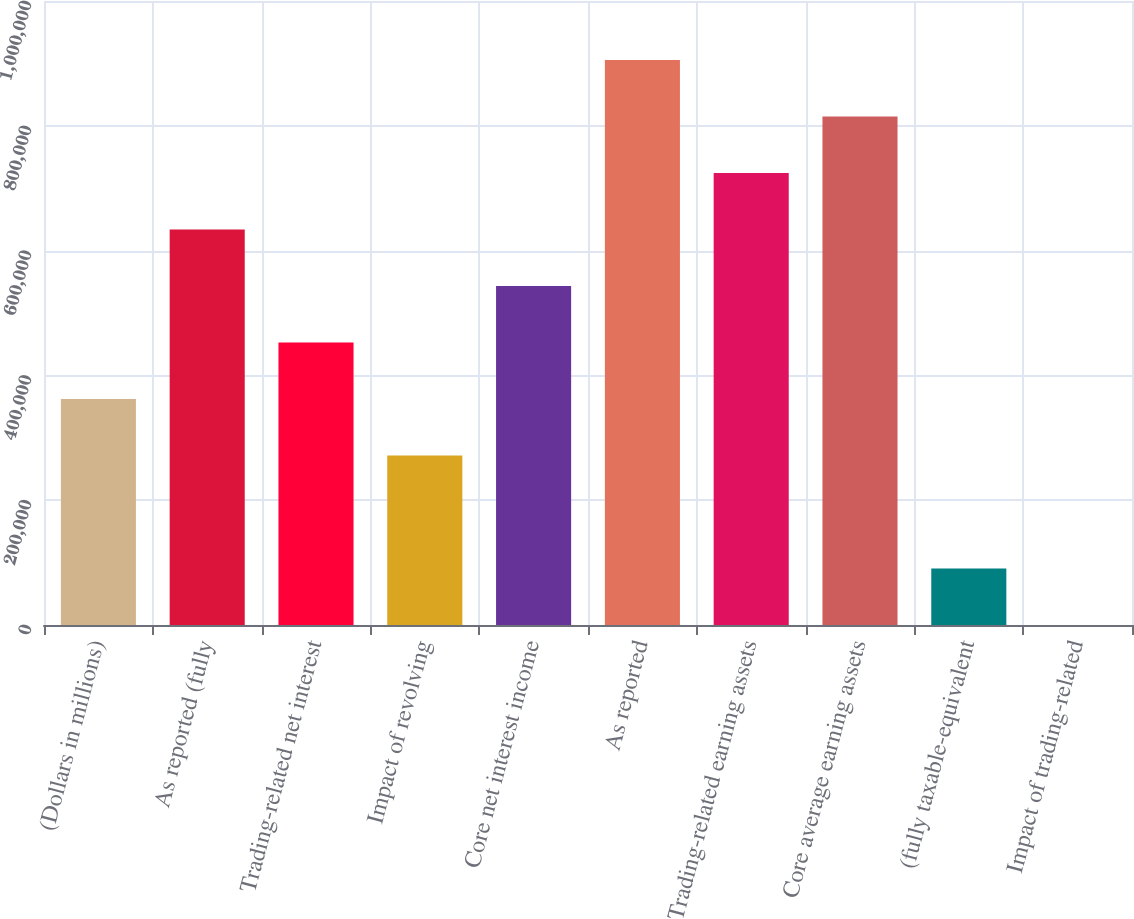<chart> <loc_0><loc_0><loc_500><loc_500><bar_chart><fcel>(Dollars in millions)<fcel>As reported (fully<fcel>Trading-related net interest<fcel>Impact of revolving<fcel>Core net interest income<fcel>As reported<fcel>Trading-related earning assets<fcel>Core average earning assets<fcel>(fully taxable-equivalent<fcel>Impact of trading-related<nl><fcel>362121<fcel>633712<fcel>452651<fcel>271591<fcel>543182<fcel>905302<fcel>724242<fcel>814772<fcel>90530.9<fcel>0.8<nl></chart> 